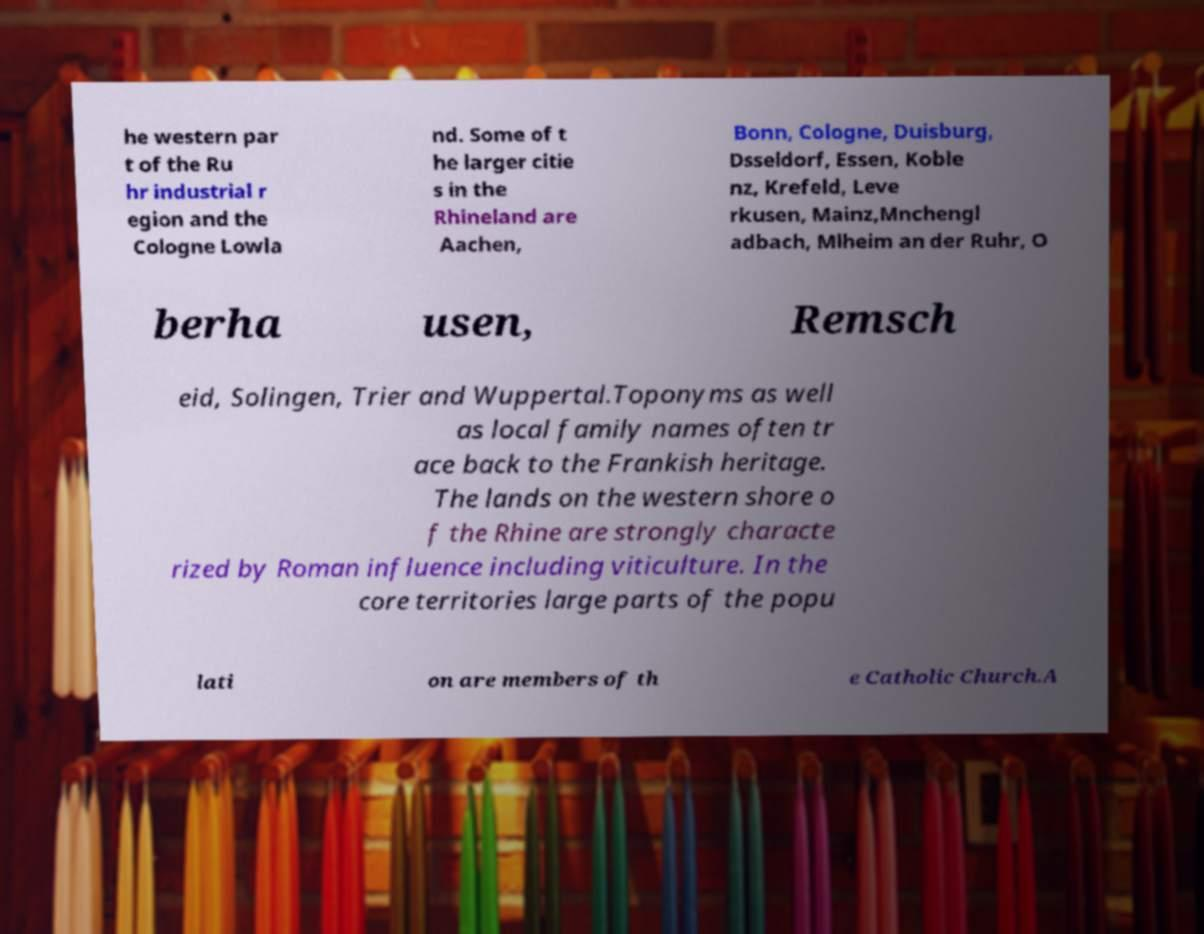Could you assist in decoding the text presented in this image and type it out clearly? he western par t of the Ru hr industrial r egion and the Cologne Lowla nd. Some of t he larger citie s in the Rhineland are Aachen, Bonn, Cologne, Duisburg, Dsseldorf, Essen, Koble nz, Krefeld, Leve rkusen, Mainz,Mnchengl adbach, Mlheim an der Ruhr, O berha usen, Remsch eid, Solingen, Trier and Wuppertal.Toponyms as well as local family names often tr ace back to the Frankish heritage. The lands on the western shore o f the Rhine are strongly characte rized by Roman influence including viticulture. In the core territories large parts of the popu lati on are members of th e Catholic Church.A 